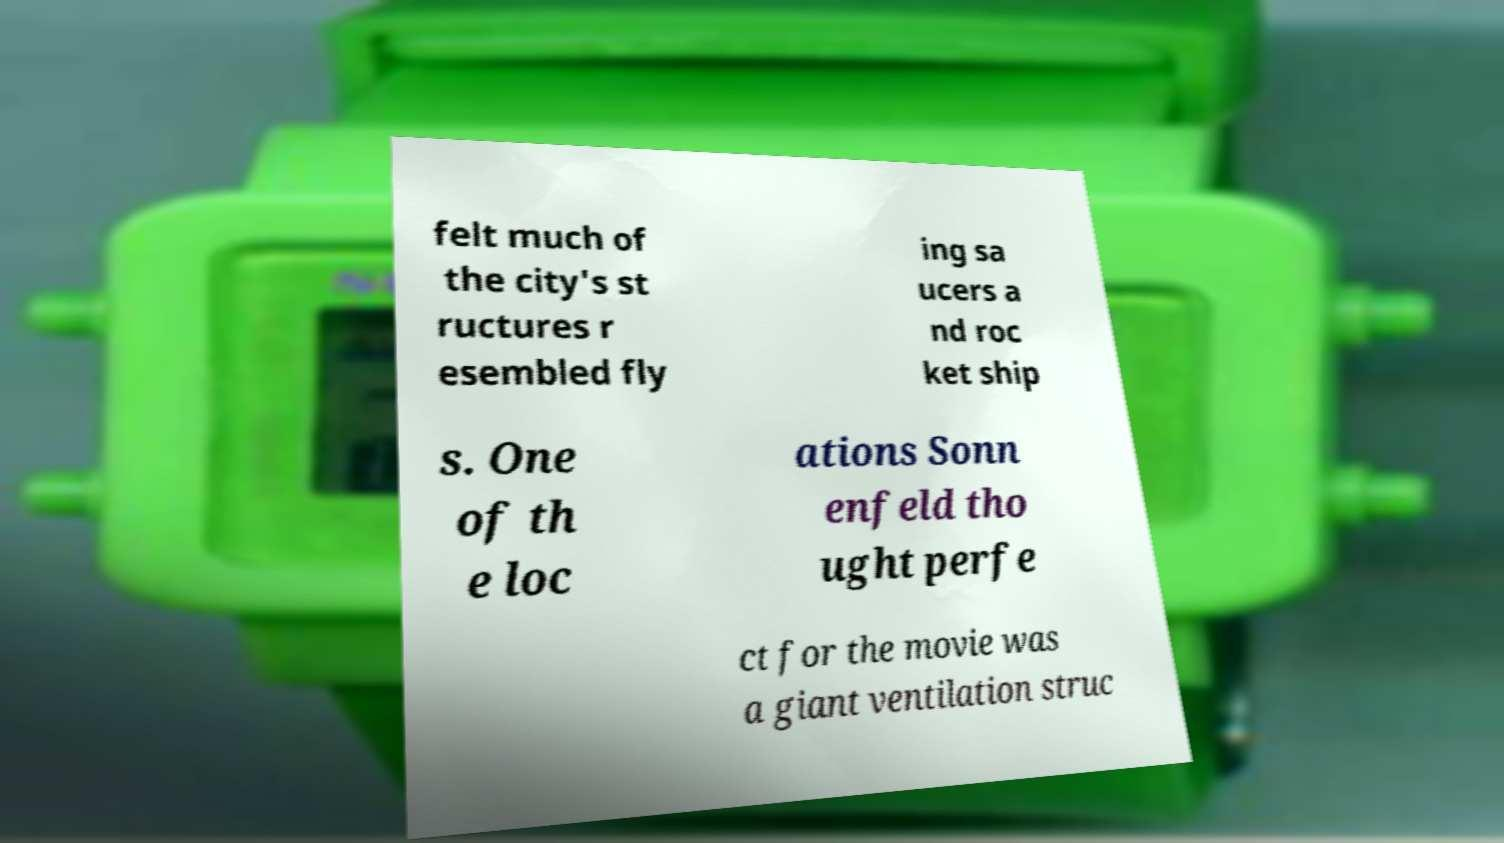Can you read and provide the text displayed in the image?This photo seems to have some interesting text. Can you extract and type it out for me? felt much of the city's st ructures r esembled fly ing sa ucers a nd roc ket ship s. One of th e loc ations Sonn enfeld tho ught perfe ct for the movie was a giant ventilation struc 